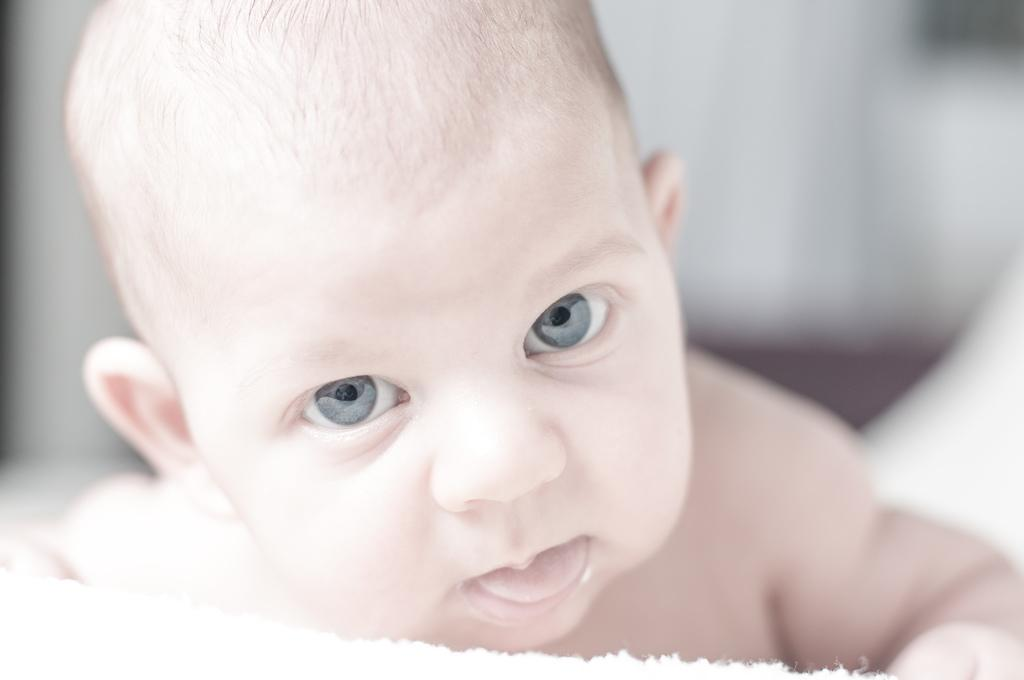What is the main subject of the picture? The main subject of the picture is a baby. What is the baby doing in the picture? The baby is sleeping in the picture. What is the baby lying on in the picture? The baby is on a white cloth in the picture. What decision did the crook make in the picture? There is no crook or decision-making process depicted in the picture; it features a sleeping baby on a white cloth. 